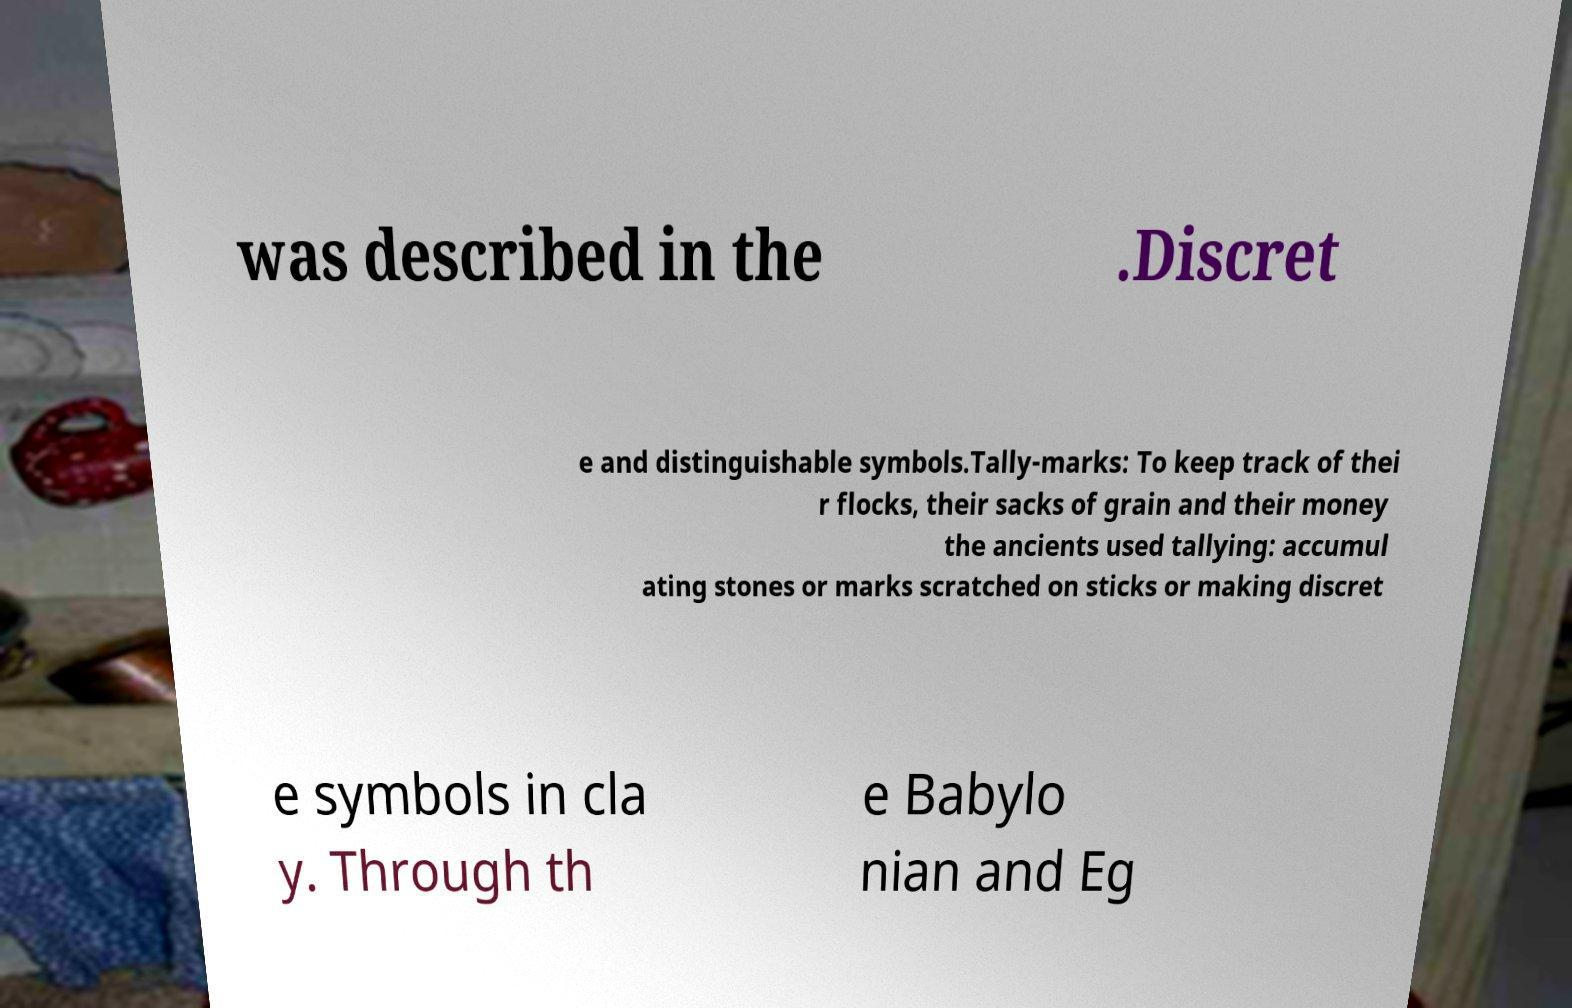Please identify and transcribe the text found in this image. was described in the .Discret e and distinguishable symbols.Tally-marks: To keep track of thei r flocks, their sacks of grain and their money the ancients used tallying: accumul ating stones or marks scratched on sticks or making discret e symbols in cla y. Through th e Babylo nian and Eg 